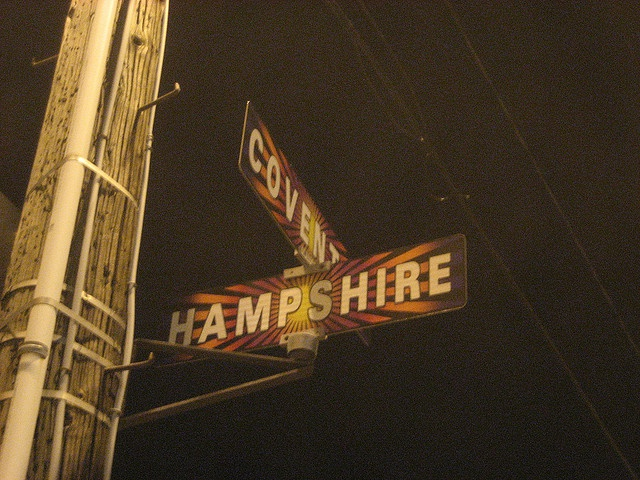Describe the objects in this image and their specific colors. I can see various objects in this image with different colors. 